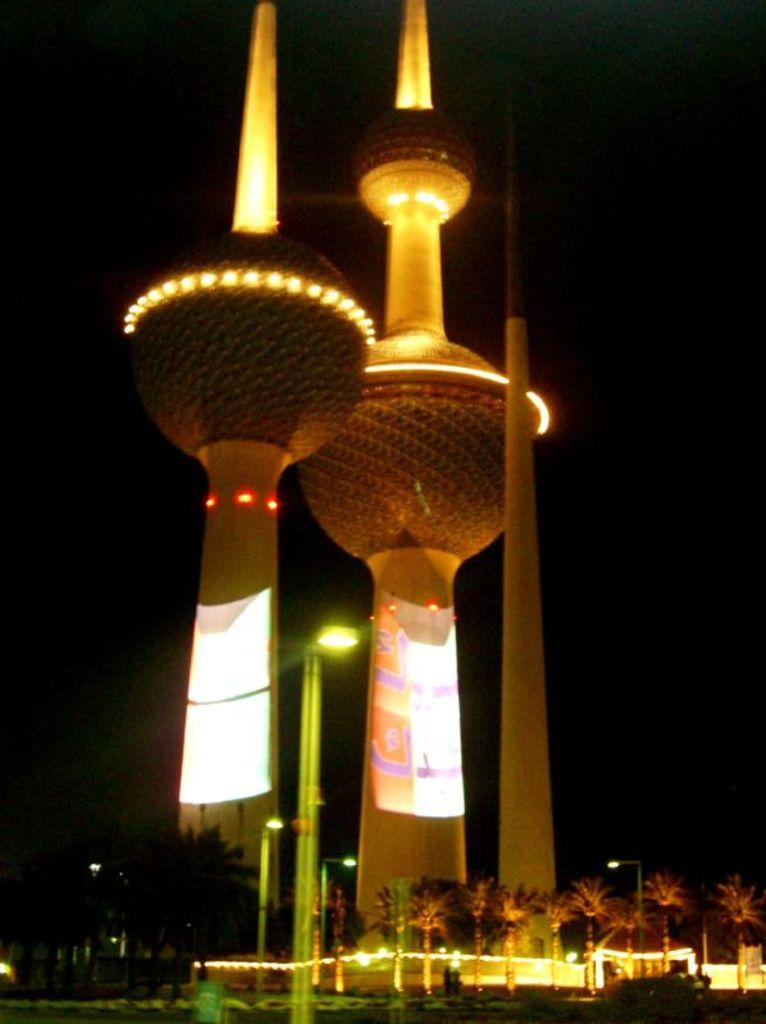What structures are visible in the image? There are towers in the image. What else can be seen in the image besides the towers? There are poles, lights, and trees in the image. How would you describe the lighting in the image? The lights in the image provide illumination. What can be observed about the background of the image? The background of the image is dark. What type of trousers are being worn by the trees in the image? There are no trousers present in the image, as trees do not wear clothing. 